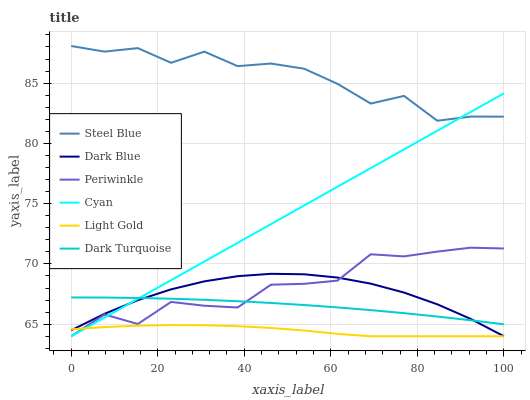Does Light Gold have the minimum area under the curve?
Answer yes or no. Yes. Does Steel Blue have the maximum area under the curve?
Answer yes or no. Yes. Does Dark Blue have the minimum area under the curve?
Answer yes or no. No. Does Dark Blue have the maximum area under the curve?
Answer yes or no. No. Is Cyan the smoothest?
Answer yes or no. Yes. Is Steel Blue the roughest?
Answer yes or no. Yes. Is Dark Blue the smoothest?
Answer yes or no. No. Is Dark Blue the roughest?
Answer yes or no. No. Does Periwinkle have the lowest value?
Answer yes or no. Yes. Does Dark Blue have the lowest value?
Answer yes or no. No. Does Steel Blue have the highest value?
Answer yes or no. Yes. Does Dark Blue have the highest value?
Answer yes or no. No. Is Dark Turquoise less than Steel Blue?
Answer yes or no. Yes. Is Steel Blue greater than Periwinkle?
Answer yes or no. Yes. Does Cyan intersect Periwinkle?
Answer yes or no. Yes. Is Cyan less than Periwinkle?
Answer yes or no. No. Is Cyan greater than Periwinkle?
Answer yes or no. No. Does Dark Turquoise intersect Steel Blue?
Answer yes or no. No. 